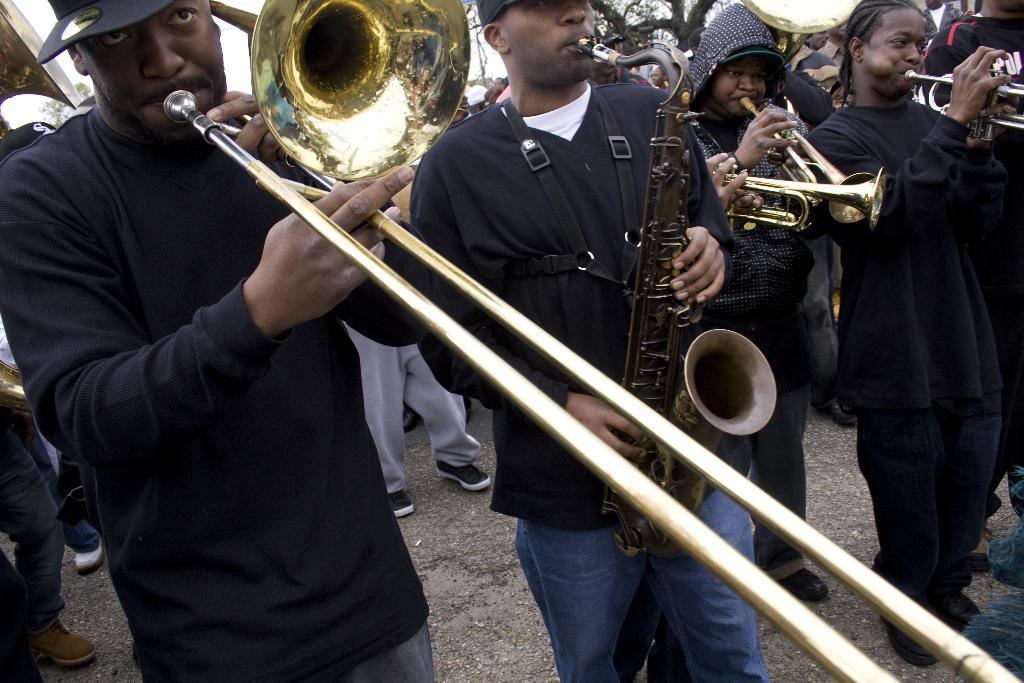What is happening in the image involving the group of people? Some of the people are holding saxophones, trombones, and trumpets, suggesting they are a musical group or band. Can you describe the instruments being held by the people? The people are holding saxophones, trombones, and trumpets. Are there any other people visible in the image? Yes, there is a group of people in the background of the image. What can be seen in the background of the image besides the people? A tree and the sky are visible in the background of the image. What type of machine is being used by the people in the image? There is no machine visible in the image; the people are holding musical instruments. Can you describe the comb being used by the people in the image? There is no comb present in the image; the people are holding musical instruments. 